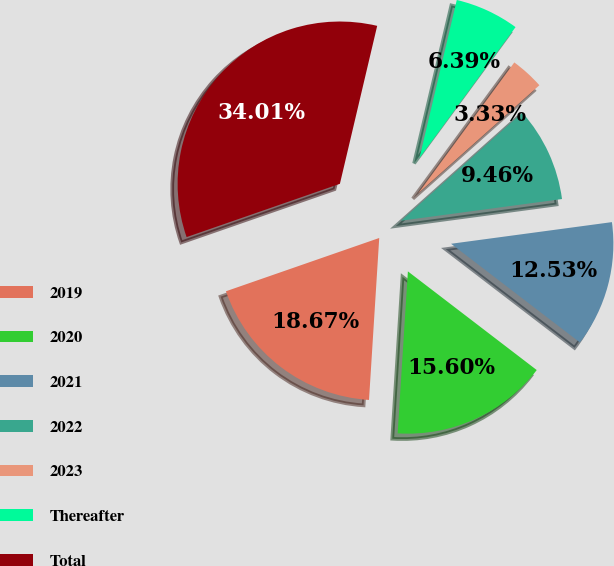Convert chart to OTSL. <chart><loc_0><loc_0><loc_500><loc_500><pie_chart><fcel>2019<fcel>2020<fcel>2021<fcel>2022<fcel>2023<fcel>Thereafter<fcel>Total<nl><fcel>18.67%<fcel>15.6%<fcel>12.53%<fcel>9.46%<fcel>3.33%<fcel>6.39%<fcel>34.01%<nl></chart> 